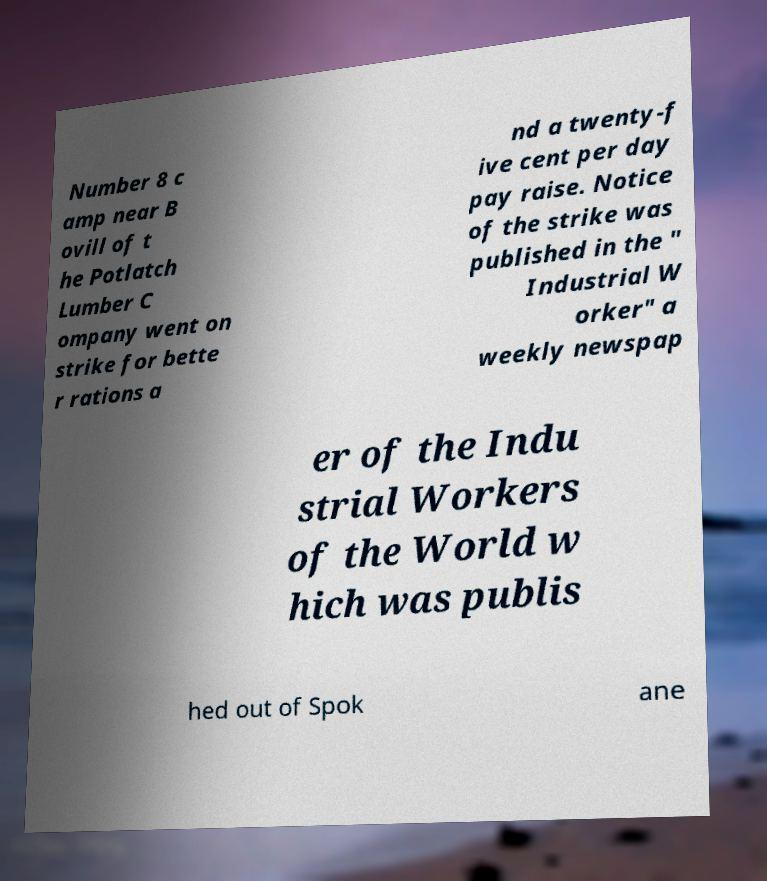I need the written content from this picture converted into text. Can you do that? Number 8 c amp near B ovill of t he Potlatch Lumber C ompany went on strike for bette r rations a nd a twenty-f ive cent per day pay raise. Notice of the strike was published in the " Industrial W orker" a weekly newspap er of the Indu strial Workers of the World w hich was publis hed out of Spok ane 